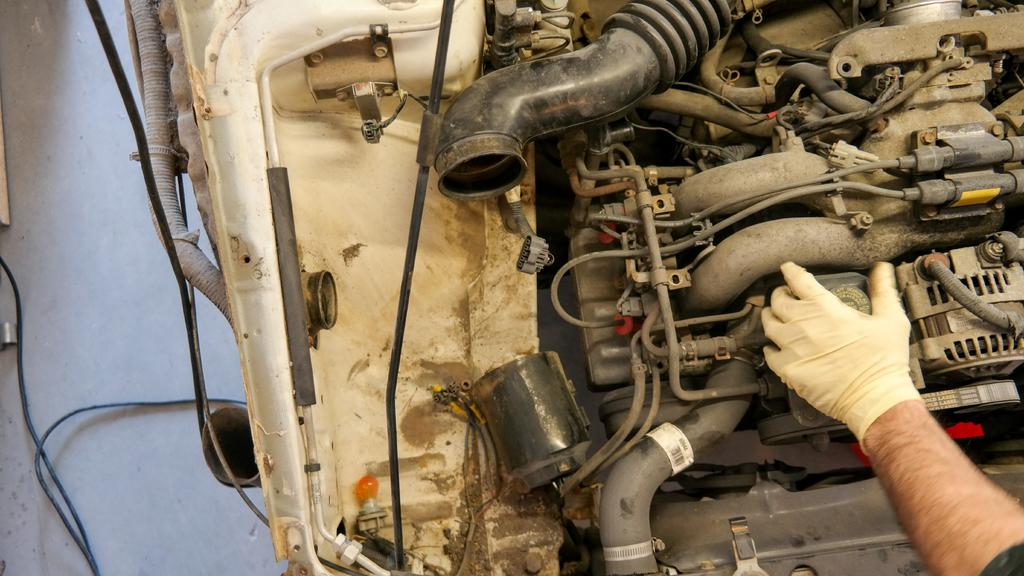What is the main subject of the image? The main subject of the image is an engine of a vehicle. Can you describe any human interaction with the engine? Yes, a man's hand is on one part of the engine. What else is visible near the engine? There are wires beside the engine. What type of pail is being used to collect mail in the image? There is no pail or mail collection activity present in the image. What type of machine is the man operating in the image? The image only shows a man's hand on an engine, and there is no indication of any machine being operated. 